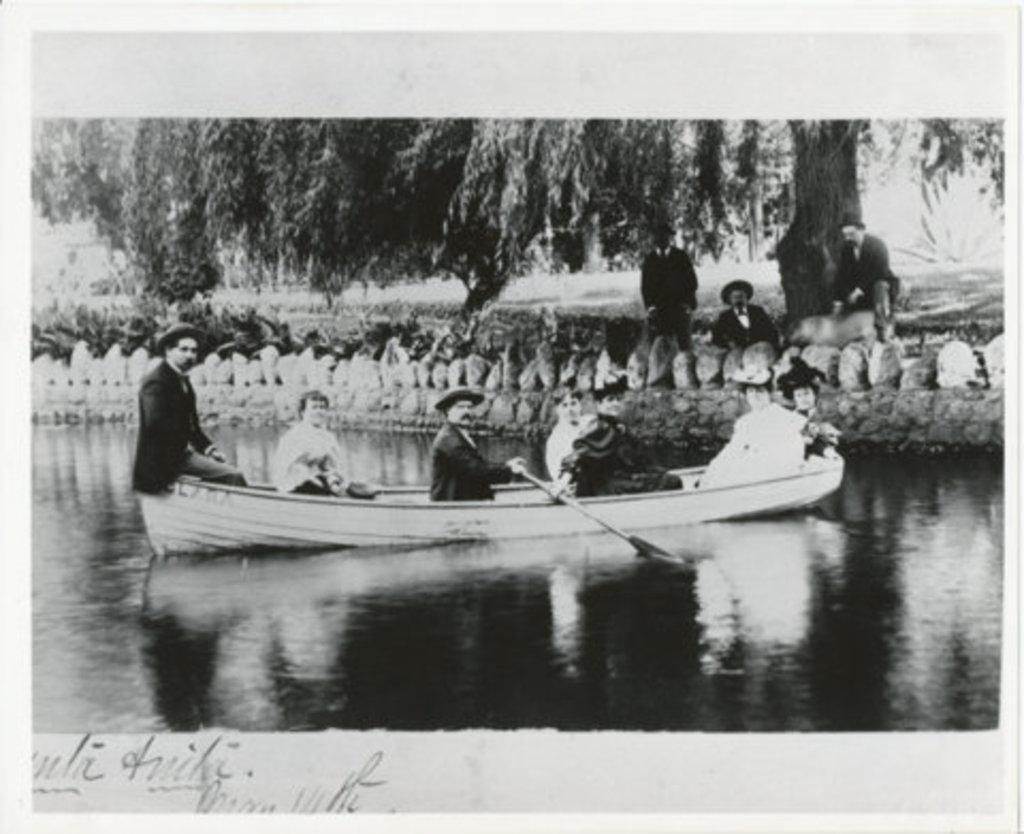Describe this image in one or two sentences. It is a black and white image, there are a group of people sailing in a boat on the river, behind the people there is a huge tree and under the tree there are three people. 